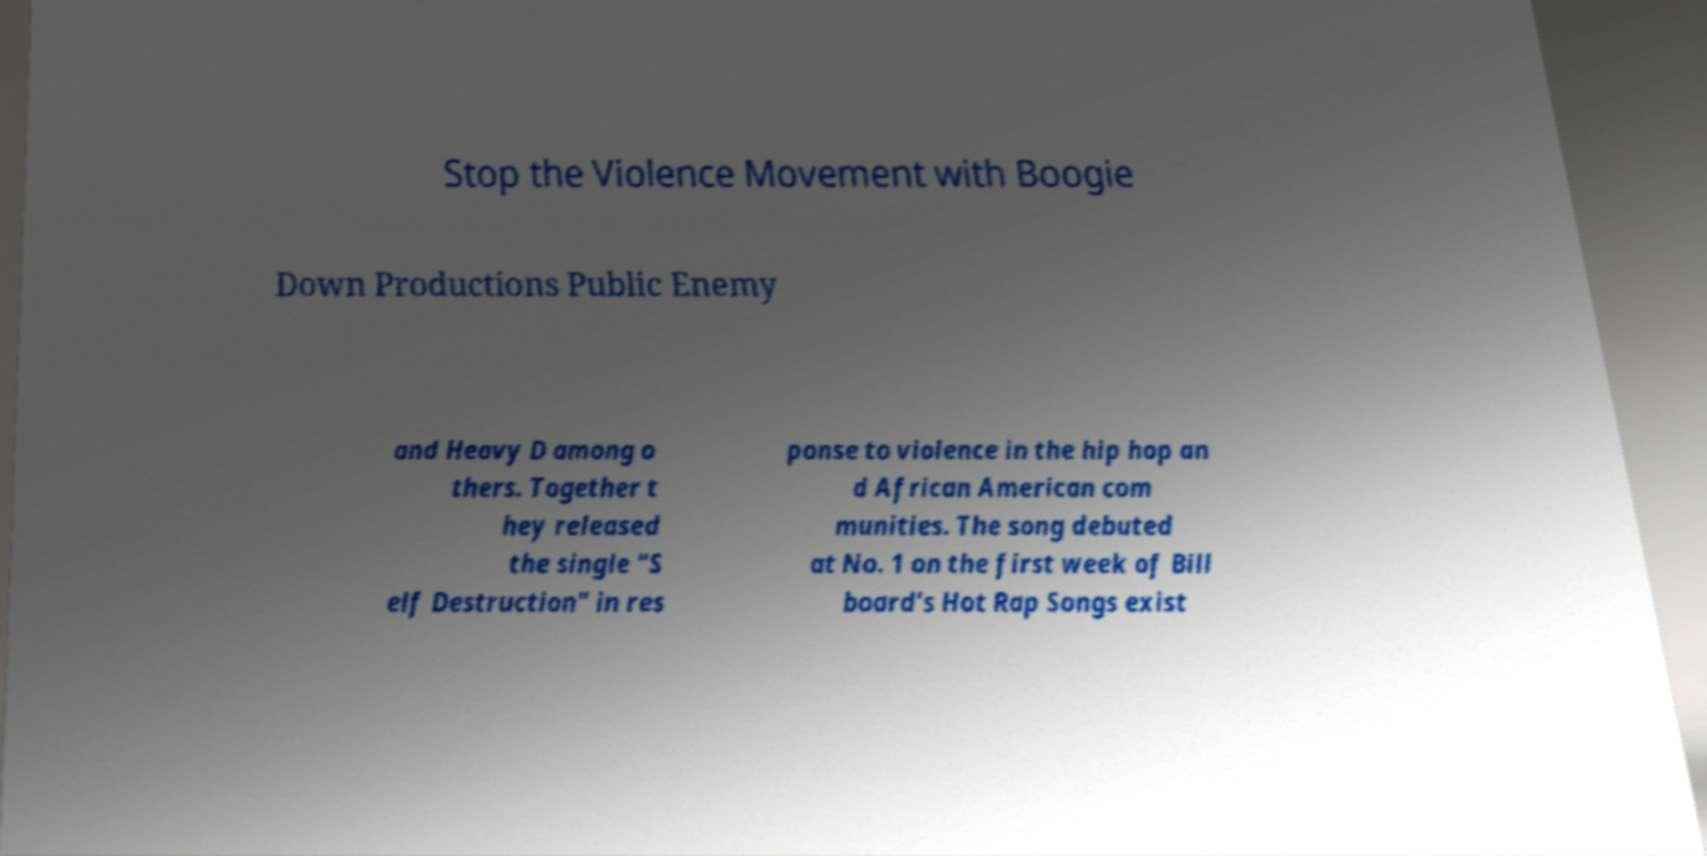Can you accurately transcribe the text from the provided image for me? Stop the Violence Movement with Boogie Down Productions Public Enemy and Heavy D among o thers. Together t hey released the single "S elf Destruction" in res ponse to violence in the hip hop an d African American com munities. The song debuted at No. 1 on the first week of Bill board's Hot Rap Songs exist 